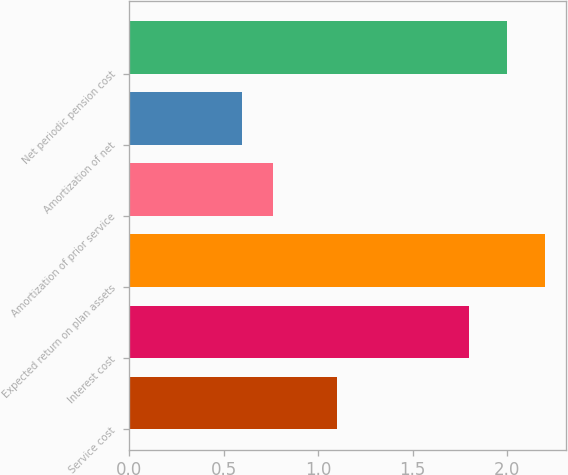Convert chart to OTSL. <chart><loc_0><loc_0><loc_500><loc_500><bar_chart><fcel>Service cost<fcel>Interest cost<fcel>Expected return on plan assets<fcel>Amortization of prior service<fcel>Amortization of net<fcel>Net periodic pension cost<nl><fcel>1.1<fcel>1.8<fcel>2.2<fcel>0.76<fcel>0.6<fcel>2<nl></chart> 